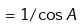<formula> <loc_0><loc_0><loc_500><loc_500>= { 1 / \cos A }</formula> 